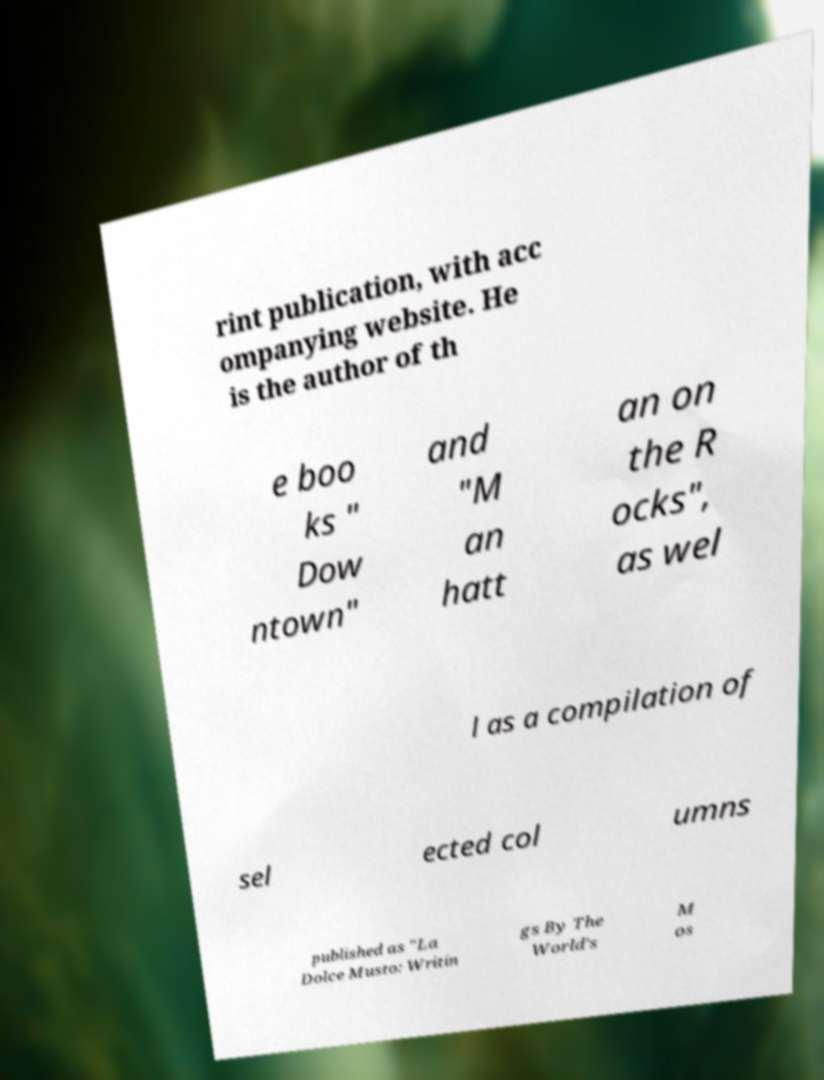Can you accurately transcribe the text from the provided image for me? rint publication, with acc ompanying website. He is the author of th e boo ks " Dow ntown" and "M an hatt an on the R ocks", as wel l as a compilation of sel ected col umns published as "La Dolce Musto: Writin gs By The World's M os 